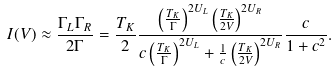<formula> <loc_0><loc_0><loc_500><loc_500>I ( V ) \approx \frac { \Gamma _ { L } \Gamma _ { R } } { 2 \Gamma } = \frac { T _ { K } } { 2 } \frac { \left ( \frac { T _ { K } } { \Gamma } \right ) ^ { 2 U _ { L } } \left ( \frac { T _ { K } } { 2 V } \right ) ^ { 2 U _ { R } } } { c \left ( \frac { T _ { K } } { \Gamma } \right ) ^ { 2 U _ { L } } + \frac { 1 } { c } \left ( \frac { T _ { K } } { 2 V } \right ) ^ { 2 U _ { R } } } \frac { c } { 1 + c ^ { 2 } } .</formula> 